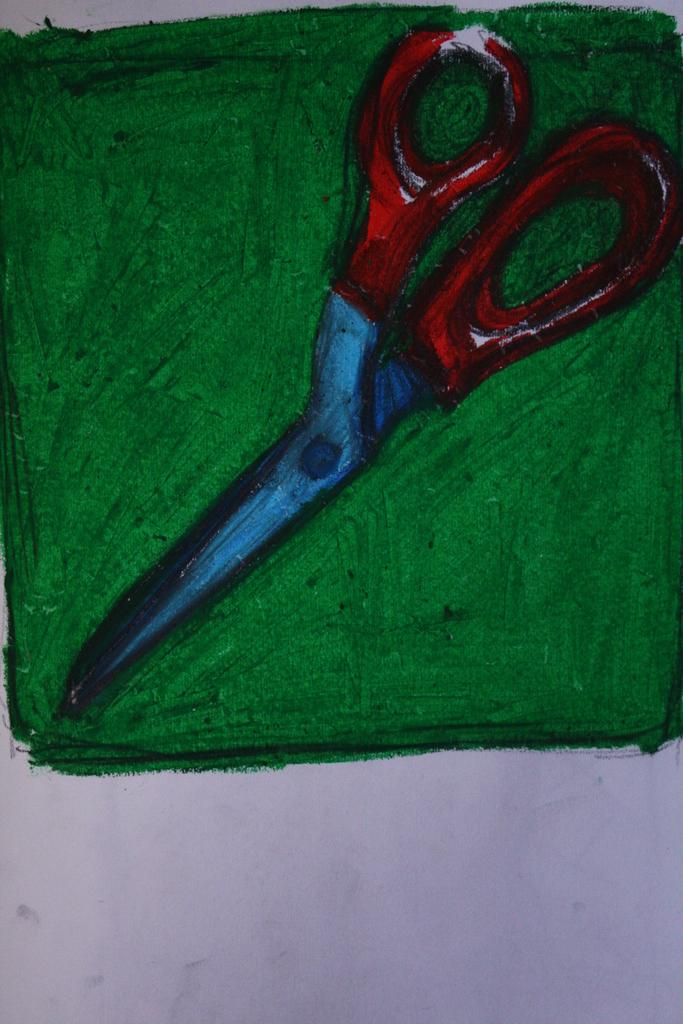What type of artwork is shown in the image? The image is a painting. What object is the main subject of the painting? The painting depicts a scissor. What color is the scissor in the painting? The scissor is in green color. Is there a pipe visible in the painting? No, there is no pipe present in the painting. Can you tell me how many times the scissor has been shocked in the painting? There is no indication of the scissor being shocked in the painting, as it is an inanimate object. 